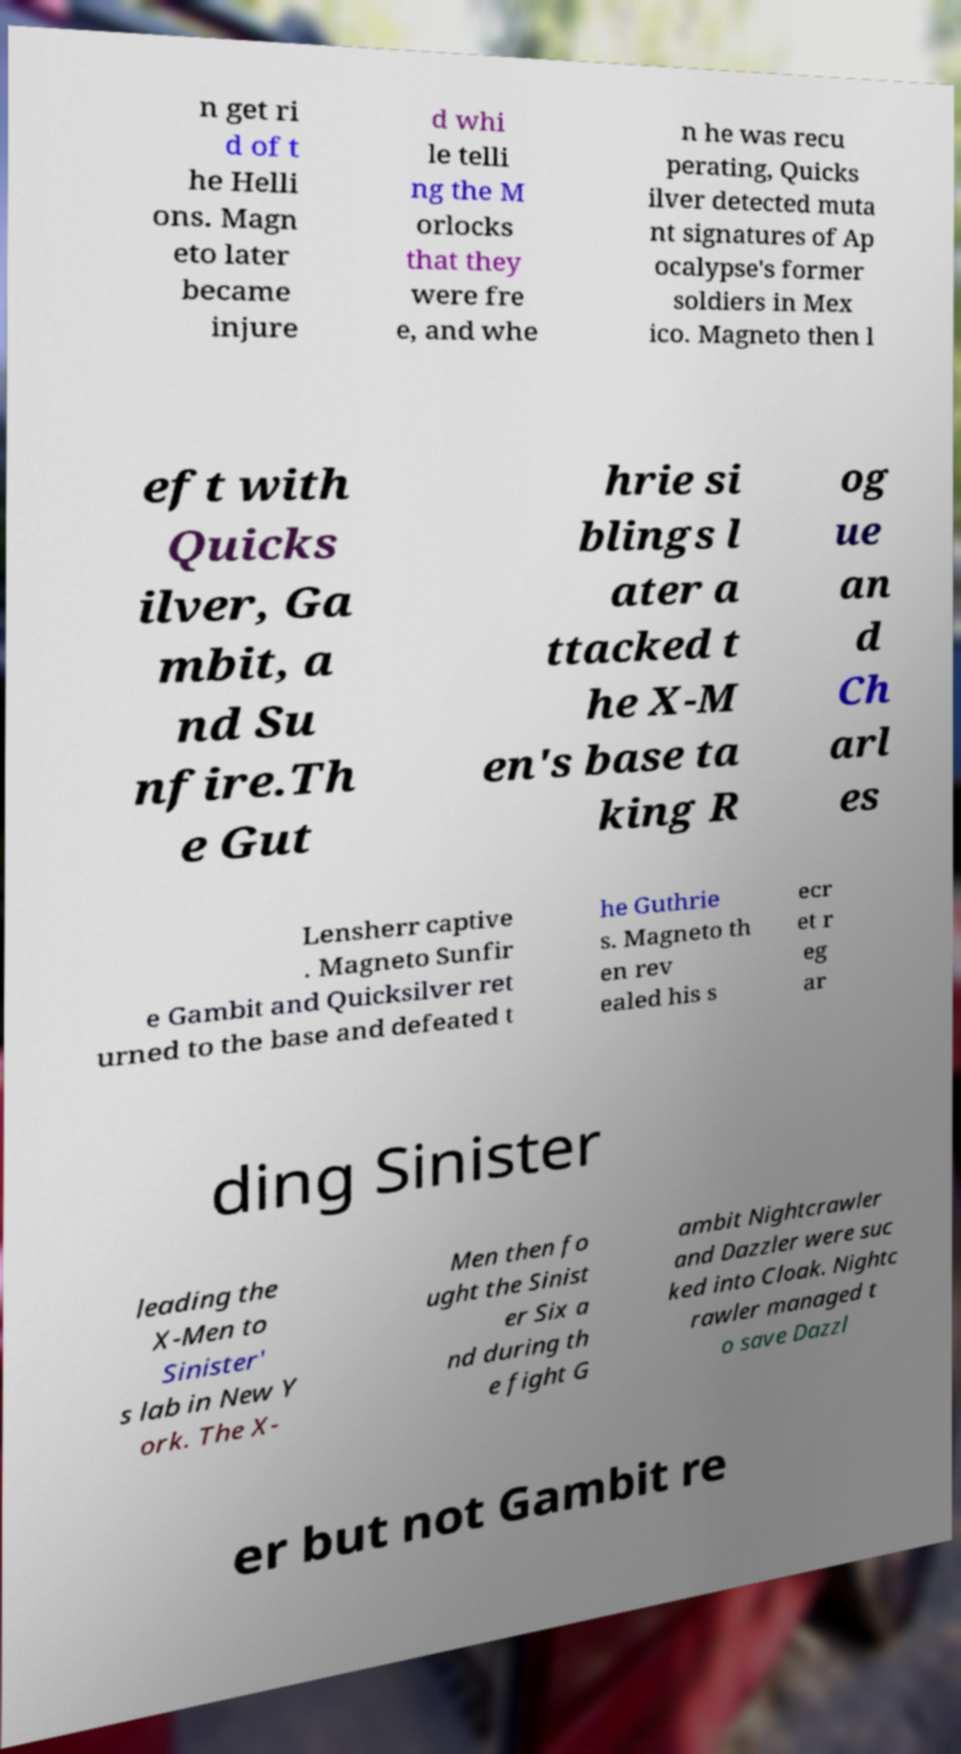Please read and relay the text visible in this image. What does it say? n get ri d of t he Helli ons. Magn eto later became injure d whi le telli ng the M orlocks that they were fre e, and whe n he was recu perating, Quicks ilver detected muta nt signatures of Ap ocalypse's former soldiers in Mex ico. Magneto then l eft with Quicks ilver, Ga mbit, a nd Su nfire.Th e Gut hrie si blings l ater a ttacked t he X-M en's base ta king R og ue an d Ch arl es Lensherr captive . Magneto Sunfir e Gambit and Quicksilver ret urned to the base and defeated t he Guthrie s. Magneto th en rev ealed his s ecr et r eg ar ding Sinister leading the X-Men to Sinister' s lab in New Y ork. The X- Men then fo ught the Sinist er Six a nd during th e fight G ambit Nightcrawler and Dazzler were suc ked into Cloak. Nightc rawler managed t o save Dazzl er but not Gambit re 